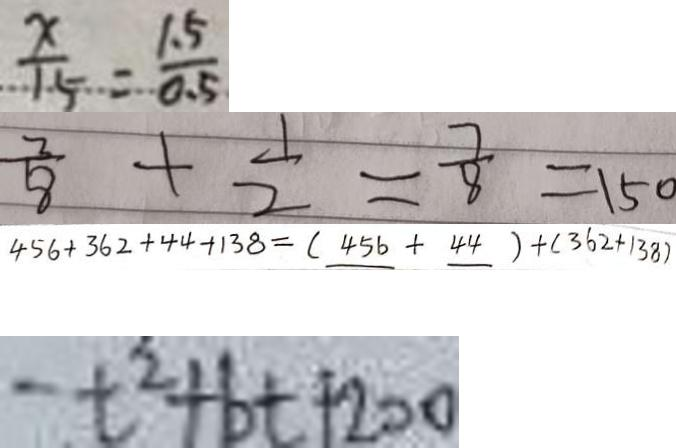Convert formula to latex. <formula><loc_0><loc_0><loc_500><loc_500>\frac { x } { 1 5 } = \frac { 1 . 5 } { 0 . 5 } 
 \frac { 3 } { 8 } + \frac { 1 } { 2 } = \frac { 7 } { 8 } = 1 5 0 
 4 5 6 + 3 6 2 + 4 4 + 1 3 8 = ( 4 5 6 + 4 4 ) + ( 3 6 2 + 1 3 8 ) 
 - t ^ { 2 } + b t + 2 0 0</formula> 